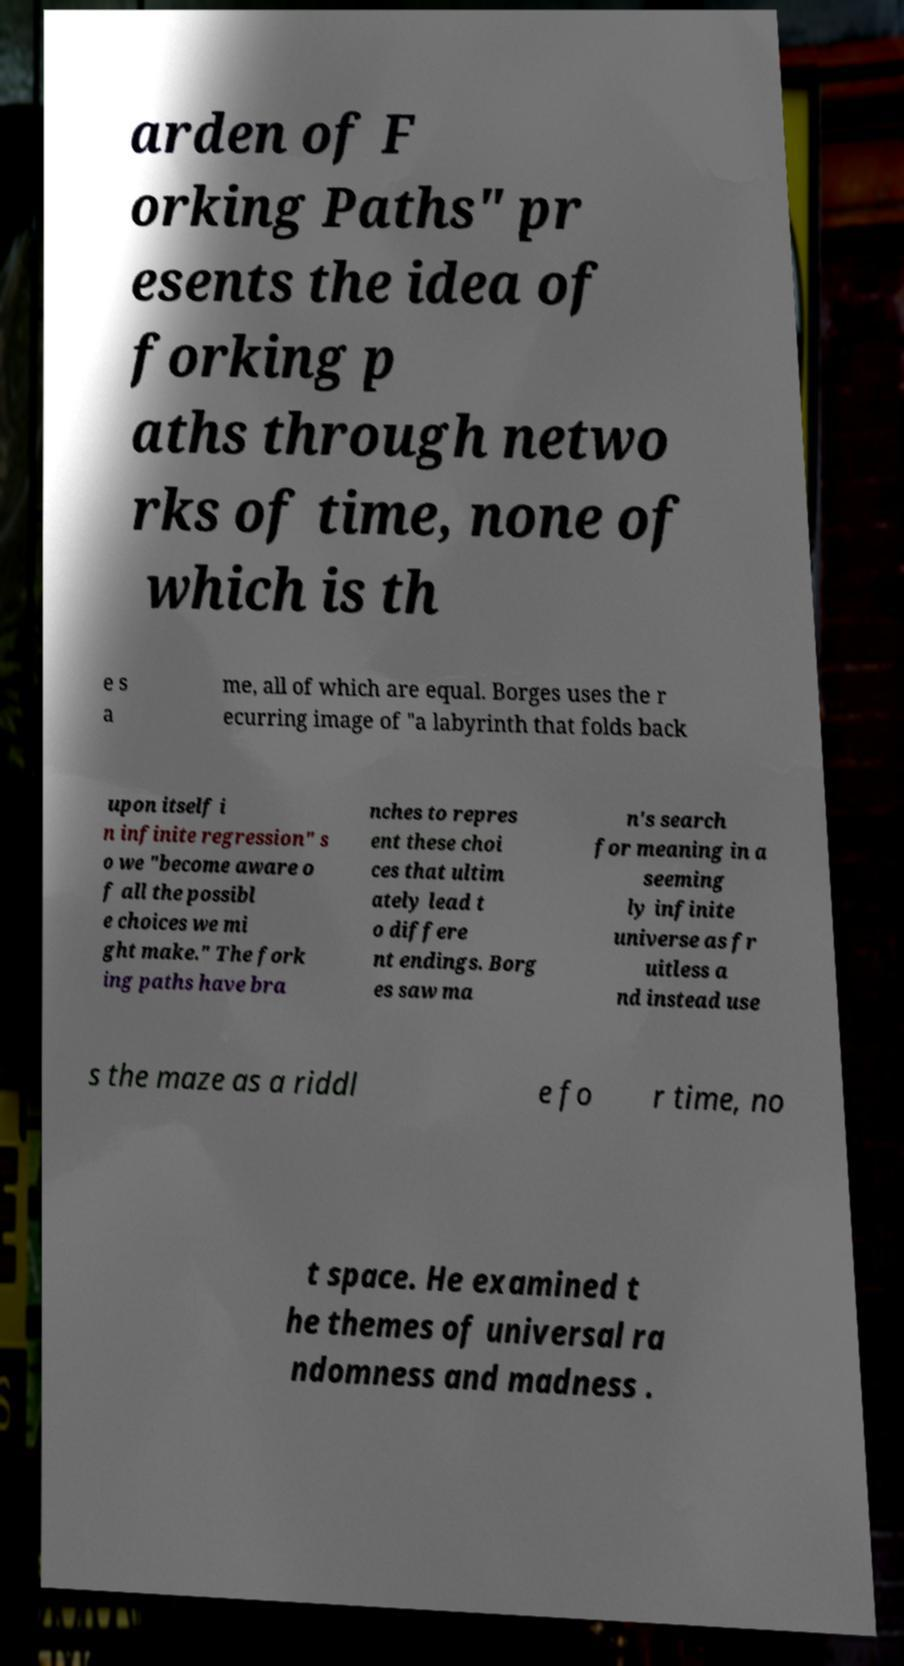Could you extract and type out the text from this image? arden of F orking Paths" pr esents the idea of forking p aths through netwo rks of time, none of which is th e s a me, all of which are equal. Borges uses the r ecurring image of "a labyrinth that folds back upon itself i n infinite regression" s o we "become aware o f all the possibl e choices we mi ght make." The fork ing paths have bra nches to repres ent these choi ces that ultim ately lead t o differe nt endings. Borg es saw ma n's search for meaning in a seeming ly infinite universe as fr uitless a nd instead use s the maze as a riddl e fo r time, no t space. He examined t he themes of universal ra ndomness and madness . 